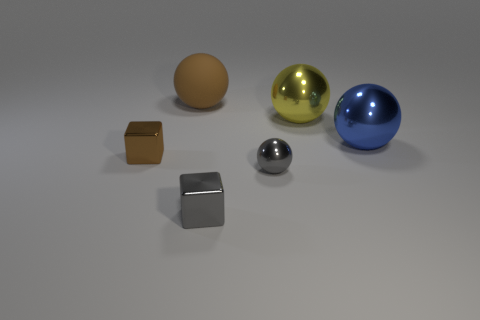Is there any other thing that is the same shape as the large matte object?
Your answer should be very brief. Yes. Does the large blue object have the same shape as the tiny brown shiny object?
Give a very brief answer. No. Are there any other things that are made of the same material as the large brown ball?
Offer a terse response. No. The yellow metal ball has what size?
Give a very brief answer. Large. There is a ball that is to the left of the yellow metal thing and in front of the yellow thing; what is its color?
Provide a succinct answer. Gray. Is the number of metal blocks greater than the number of big rubber objects?
Keep it short and to the point. Yes. How many things are either small metal blocks or balls that are left of the blue ball?
Provide a short and direct response. 5. Do the brown matte ball and the gray metallic block have the same size?
Your response must be concise. No. There is a large rubber object; are there any small balls left of it?
Offer a very short reply. No. What is the size of the metal object that is both on the left side of the tiny gray metallic sphere and behind the tiny ball?
Offer a terse response. Small. 